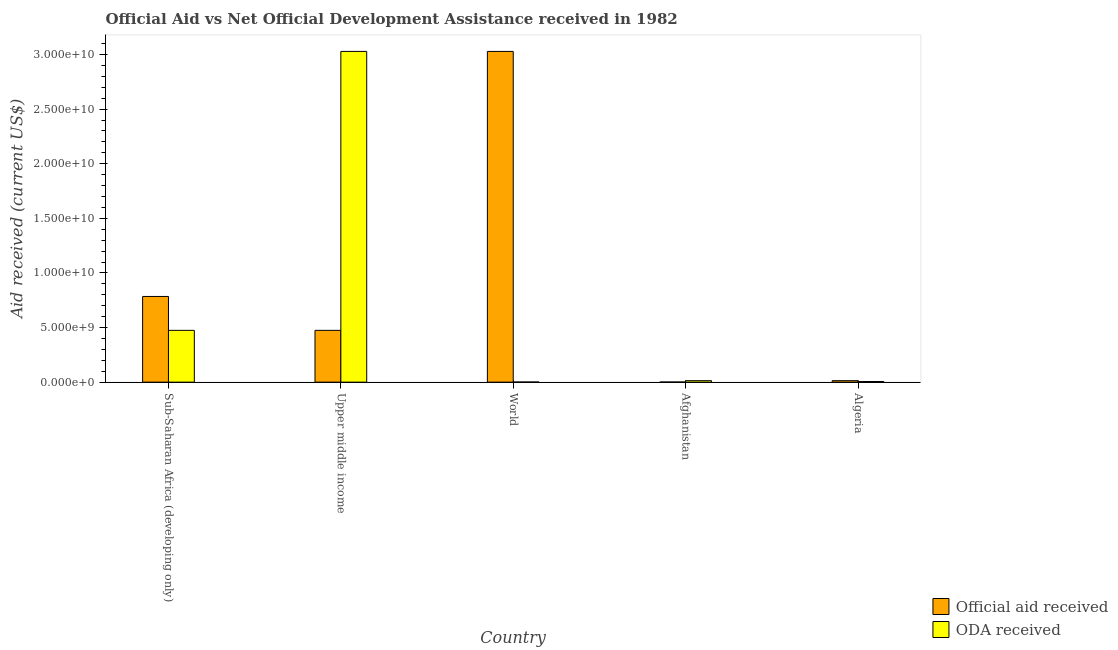How many different coloured bars are there?
Ensure brevity in your answer.  2. How many groups of bars are there?
Give a very brief answer. 5. Are the number of bars per tick equal to the number of legend labels?
Keep it short and to the point. Yes. Are the number of bars on each tick of the X-axis equal?
Your answer should be very brief. Yes. What is the label of the 3rd group of bars from the left?
Provide a short and direct response. World. In how many cases, is the number of bars for a given country not equal to the number of legend labels?
Your answer should be compact. 0. What is the oda received in Algeria?
Your response must be concise. 5.91e+07. Across all countries, what is the maximum official aid received?
Keep it short and to the point. 3.03e+1. Across all countries, what is the minimum oda received?
Your answer should be very brief. 9.33e+06. In which country was the oda received minimum?
Offer a very short reply. World. What is the total official aid received in the graph?
Keep it short and to the point. 4.30e+1. What is the difference between the official aid received in Upper middle income and that in World?
Provide a succinct answer. -2.55e+1. What is the difference between the official aid received in Afghanistan and the oda received in Algeria?
Provide a short and direct response. -4.97e+07. What is the average oda received per country?
Give a very brief answer. 7.05e+09. What is the difference between the official aid received and oda received in Sub-Saharan Africa (developing only)?
Provide a succinct answer. 3.10e+09. What is the ratio of the oda received in Sub-Saharan Africa (developing only) to that in Upper middle income?
Your answer should be compact. 0.16. Is the oda received in Afghanistan less than that in Upper middle income?
Your answer should be very brief. Yes. What is the difference between the highest and the second highest official aid received?
Ensure brevity in your answer.  2.24e+1. What is the difference between the highest and the lowest official aid received?
Offer a very short reply. 3.03e+1. In how many countries, is the oda received greater than the average oda received taken over all countries?
Provide a succinct answer. 1. What does the 1st bar from the left in Afghanistan represents?
Your response must be concise. Official aid received. What does the 2nd bar from the right in Sub-Saharan Africa (developing only) represents?
Provide a short and direct response. Official aid received. Are all the bars in the graph horizontal?
Offer a terse response. No. Are the values on the major ticks of Y-axis written in scientific E-notation?
Provide a succinct answer. Yes. Does the graph contain any zero values?
Provide a short and direct response. No. Where does the legend appear in the graph?
Provide a short and direct response. Bottom right. How many legend labels are there?
Offer a terse response. 2. How are the legend labels stacked?
Give a very brief answer. Vertical. What is the title of the graph?
Provide a short and direct response. Official Aid vs Net Official Development Assistance received in 1982 . What is the label or title of the X-axis?
Offer a very short reply. Country. What is the label or title of the Y-axis?
Make the answer very short. Aid received (current US$). What is the Aid received (current US$) in Official aid received in Sub-Saharan Africa (developing only)?
Ensure brevity in your answer.  7.85e+09. What is the Aid received (current US$) of ODA received in Sub-Saharan Africa (developing only)?
Give a very brief answer. 4.74e+09. What is the Aid received (current US$) in Official aid received in Upper middle income?
Make the answer very short. 4.74e+09. What is the Aid received (current US$) of ODA received in Upper middle income?
Give a very brief answer. 3.03e+1. What is the Aid received (current US$) of Official aid received in World?
Offer a very short reply. 3.03e+1. What is the Aid received (current US$) in ODA received in World?
Make the answer very short. 9.33e+06. What is the Aid received (current US$) of Official aid received in Afghanistan?
Provide a short and direct response. 9.33e+06. What is the Aid received (current US$) of ODA received in Afghanistan?
Give a very brief answer. 1.35e+08. What is the Aid received (current US$) in Official aid received in Algeria?
Give a very brief answer. 1.35e+08. What is the Aid received (current US$) in ODA received in Algeria?
Keep it short and to the point. 5.91e+07. Across all countries, what is the maximum Aid received (current US$) in Official aid received?
Make the answer very short. 3.03e+1. Across all countries, what is the maximum Aid received (current US$) of ODA received?
Ensure brevity in your answer.  3.03e+1. Across all countries, what is the minimum Aid received (current US$) of Official aid received?
Ensure brevity in your answer.  9.33e+06. Across all countries, what is the minimum Aid received (current US$) of ODA received?
Your response must be concise. 9.33e+06. What is the total Aid received (current US$) in Official aid received in the graph?
Provide a succinct answer. 4.30e+1. What is the total Aid received (current US$) in ODA received in the graph?
Your answer should be very brief. 3.52e+1. What is the difference between the Aid received (current US$) of Official aid received in Sub-Saharan Africa (developing only) and that in Upper middle income?
Offer a very short reply. 3.10e+09. What is the difference between the Aid received (current US$) in ODA received in Sub-Saharan Africa (developing only) and that in Upper middle income?
Your response must be concise. -2.55e+1. What is the difference between the Aid received (current US$) of Official aid received in Sub-Saharan Africa (developing only) and that in World?
Offer a terse response. -2.24e+1. What is the difference between the Aid received (current US$) in ODA received in Sub-Saharan Africa (developing only) and that in World?
Give a very brief answer. 4.73e+09. What is the difference between the Aid received (current US$) of Official aid received in Sub-Saharan Africa (developing only) and that in Afghanistan?
Your response must be concise. 7.84e+09. What is the difference between the Aid received (current US$) of ODA received in Sub-Saharan Africa (developing only) and that in Afghanistan?
Provide a short and direct response. 4.61e+09. What is the difference between the Aid received (current US$) in Official aid received in Sub-Saharan Africa (developing only) and that in Algeria?
Offer a very short reply. 7.71e+09. What is the difference between the Aid received (current US$) in ODA received in Sub-Saharan Africa (developing only) and that in Algeria?
Your answer should be very brief. 4.68e+09. What is the difference between the Aid received (current US$) in Official aid received in Upper middle income and that in World?
Provide a short and direct response. -2.55e+1. What is the difference between the Aid received (current US$) in ODA received in Upper middle income and that in World?
Ensure brevity in your answer.  3.03e+1. What is the difference between the Aid received (current US$) of Official aid received in Upper middle income and that in Afghanistan?
Ensure brevity in your answer.  4.73e+09. What is the difference between the Aid received (current US$) in ODA received in Upper middle income and that in Afghanistan?
Your answer should be compact. 3.01e+1. What is the difference between the Aid received (current US$) of Official aid received in Upper middle income and that in Algeria?
Provide a short and direct response. 4.61e+09. What is the difference between the Aid received (current US$) of ODA received in Upper middle income and that in Algeria?
Offer a very short reply. 3.02e+1. What is the difference between the Aid received (current US$) of Official aid received in World and that in Afghanistan?
Make the answer very short. 3.03e+1. What is the difference between the Aid received (current US$) in ODA received in World and that in Afghanistan?
Offer a very short reply. -1.25e+08. What is the difference between the Aid received (current US$) of Official aid received in World and that in Algeria?
Ensure brevity in your answer.  3.01e+1. What is the difference between the Aid received (current US$) of ODA received in World and that in Algeria?
Your response must be concise. -4.97e+07. What is the difference between the Aid received (current US$) of Official aid received in Afghanistan and that in Algeria?
Provide a short and direct response. -1.25e+08. What is the difference between the Aid received (current US$) of ODA received in Afghanistan and that in Algeria?
Your response must be concise. 7.56e+07. What is the difference between the Aid received (current US$) in Official aid received in Sub-Saharan Africa (developing only) and the Aid received (current US$) in ODA received in Upper middle income?
Provide a short and direct response. -2.24e+1. What is the difference between the Aid received (current US$) in Official aid received in Sub-Saharan Africa (developing only) and the Aid received (current US$) in ODA received in World?
Your response must be concise. 7.84e+09. What is the difference between the Aid received (current US$) in Official aid received in Sub-Saharan Africa (developing only) and the Aid received (current US$) in ODA received in Afghanistan?
Keep it short and to the point. 7.71e+09. What is the difference between the Aid received (current US$) in Official aid received in Sub-Saharan Africa (developing only) and the Aid received (current US$) in ODA received in Algeria?
Provide a short and direct response. 7.79e+09. What is the difference between the Aid received (current US$) in Official aid received in Upper middle income and the Aid received (current US$) in ODA received in World?
Ensure brevity in your answer.  4.73e+09. What is the difference between the Aid received (current US$) of Official aid received in Upper middle income and the Aid received (current US$) of ODA received in Afghanistan?
Provide a succinct answer. 4.61e+09. What is the difference between the Aid received (current US$) of Official aid received in Upper middle income and the Aid received (current US$) of ODA received in Algeria?
Your answer should be very brief. 4.68e+09. What is the difference between the Aid received (current US$) in Official aid received in World and the Aid received (current US$) in ODA received in Afghanistan?
Offer a terse response. 3.01e+1. What is the difference between the Aid received (current US$) of Official aid received in World and the Aid received (current US$) of ODA received in Algeria?
Your answer should be very brief. 3.02e+1. What is the difference between the Aid received (current US$) in Official aid received in Afghanistan and the Aid received (current US$) in ODA received in Algeria?
Provide a short and direct response. -4.97e+07. What is the average Aid received (current US$) of Official aid received per country?
Make the answer very short. 8.60e+09. What is the average Aid received (current US$) in ODA received per country?
Ensure brevity in your answer.  7.05e+09. What is the difference between the Aid received (current US$) in Official aid received and Aid received (current US$) in ODA received in Sub-Saharan Africa (developing only)?
Offer a terse response. 3.10e+09. What is the difference between the Aid received (current US$) in Official aid received and Aid received (current US$) in ODA received in Upper middle income?
Offer a very short reply. -2.55e+1. What is the difference between the Aid received (current US$) in Official aid received and Aid received (current US$) in ODA received in World?
Provide a succinct answer. 3.03e+1. What is the difference between the Aid received (current US$) in Official aid received and Aid received (current US$) in ODA received in Afghanistan?
Your answer should be very brief. -1.25e+08. What is the difference between the Aid received (current US$) in Official aid received and Aid received (current US$) in ODA received in Algeria?
Make the answer very short. 7.56e+07. What is the ratio of the Aid received (current US$) in Official aid received in Sub-Saharan Africa (developing only) to that in Upper middle income?
Ensure brevity in your answer.  1.65. What is the ratio of the Aid received (current US$) in ODA received in Sub-Saharan Africa (developing only) to that in Upper middle income?
Offer a terse response. 0.16. What is the ratio of the Aid received (current US$) of Official aid received in Sub-Saharan Africa (developing only) to that in World?
Your answer should be very brief. 0.26. What is the ratio of the Aid received (current US$) in ODA received in Sub-Saharan Africa (developing only) to that in World?
Make the answer very short. 508.37. What is the ratio of the Aid received (current US$) of Official aid received in Sub-Saharan Africa (developing only) to that in Afghanistan?
Your response must be concise. 840.96. What is the ratio of the Aid received (current US$) of ODA received in Sub-Saharan Africa (developing only) to that in Afghanistan?
Offer a very short reply. 35.21. What is the ratio of the Aid received (current US$) in Official aid received in Sub-Saharan Africa (developing only) to that in Algeria?
Offer a terse response. 58.25. What is the ratio of the Aid received (current US$) in ODA received in Sub-Saharan Africa (developing only) to that in Algeria?
Your response must be concise. 80.3. What is the ratio of the Aid received (current US$) of Official aid received in Upper middle income to that in World?
Your response must be concise. 0.16. What is the ratio of the Aid received (current US$) of ODA received in Upper middle income to that in World?
Offer a terse response. 3245.69. What is the ratio of the Aid received (current US$) of Official aid received in Upper middle income to that in Afghanistan?
Make the answer very short. 508.37. What is the ratio of the Aid received (current US$) in ODA received in Upper middle income to that in Afghanistan?
Offer a very short reply. 224.81. What is the ratio of the Aid received (current US$) of Official aid received in Upper middle income to that in Algeria?
Your answer should be compact. 35.21. What is the ratio of the Aid received (current US$) of ODA received in Upper middle income to that in Algeria?
Provide a short and direct response. 512.65. What is the ratio of the Aid received (current US$) of Official aid received in World to that in Afghanistan?
Your response must be concise. 3245.69. What is the ratio of the Aid received (current US$) of ODA received in World to that in Afghanistan?
Your response must be concise. 0.07. What is the ratio of the Aid received (current US$) of Official aid received in World to that in Algeria?
Provide a short and direct response. 224.81. What is the ratio of the Aid received (current US$) of ODA received in World to that in Algeria?
Offer a terse response. 0.16. What is the ratio of the Aid received (current US$) of Official aid received in Afghanistan to that in Algeria?
Offer a terse response. 0.07. What is the ratio of the Aid received (current US$) of ODA received in Afghanistan to that in Algeria?
Provide a short and direct response. 2.28. What is the difference between the highest and the second highest Aid received (current US$) in Official aid received?
Ensure brevity in your answer.  2.24e+1. What is the difference between the highest and the second highest Aid received (current US$) in ODA received?
Provide a succinct answer. 2.55e+1. What is the difference between the highest and the lowest Aid received (current US$) of Official aid received?
Make the answer very short. 3.03e+1. What is the difference between the highest and the lowest Aid received (current US$) of ODA received?
Make the answer very short. 3.03e+1. 